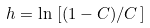Convert formula to latex. <formula><loc_0><loc_0><loc_500><loc_500>h = \ln { \, [ ( 1 - C ) / C \, ] }</formula> 